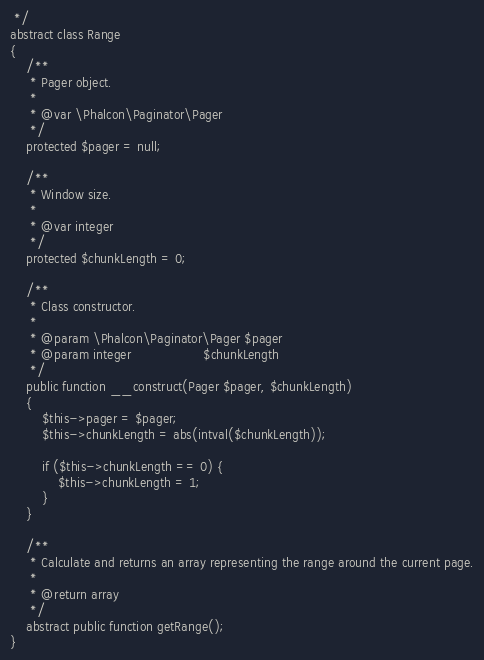<code> <loc_0><loc_0><loc_500><loc_500><_PHP_> */
abstract class Range
{
    /**
     * Pager object.
     *
     * @var \Phalcon\Paginator\Pager
     */
    protected $pager = null;

    /**
     * Window size.
     *
     * @var integer
     */
    protected $chunkLength = 0;

    /**
     * Class constructor.
     *
     * @param \Phalcon\Paginator\Pager $pager
     * @param integer                  $chunkLength
     */
    public function __construct(Pager $pager, $chunkLength)
    {
        $this->pager = $pager;
        $this->chunkLength = abs(intval($chunkLength));

        if ($this->chunkLength == 0) {
            $this->chunkLength = 1;
        }
    }

    /**
     * Calculate and returns an array representing the range around the current page.
     *
     * @return array
     */
    abstract public function getRange();
}
</code> 